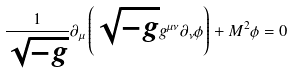<formula> <loc_0><loc_0><loc_500><loc_500>\frac { 1 } { \sqrt { - g } } \partial _ { \mu } \left ( \sqrt { - g } g ^ { \mu \nu } \partial _ { \nu } \phi \right ) + M ^ { 2 } \phi = 0</formula> 